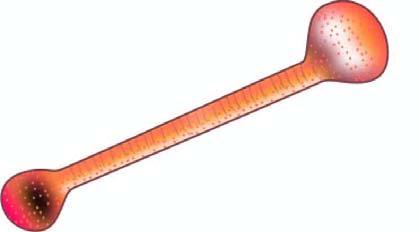what is an asbestos fibre coated with giving it beaded or dumbbell-shaped appearance with bulbous ends?
Answer the question using a single word or phrase. Asbestos body 